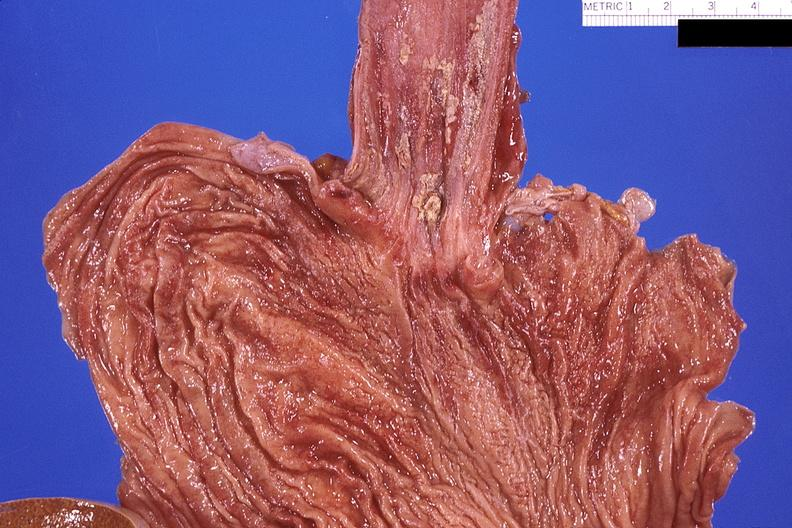s hematoma present?
Answer the question using a single word or phrase. No 